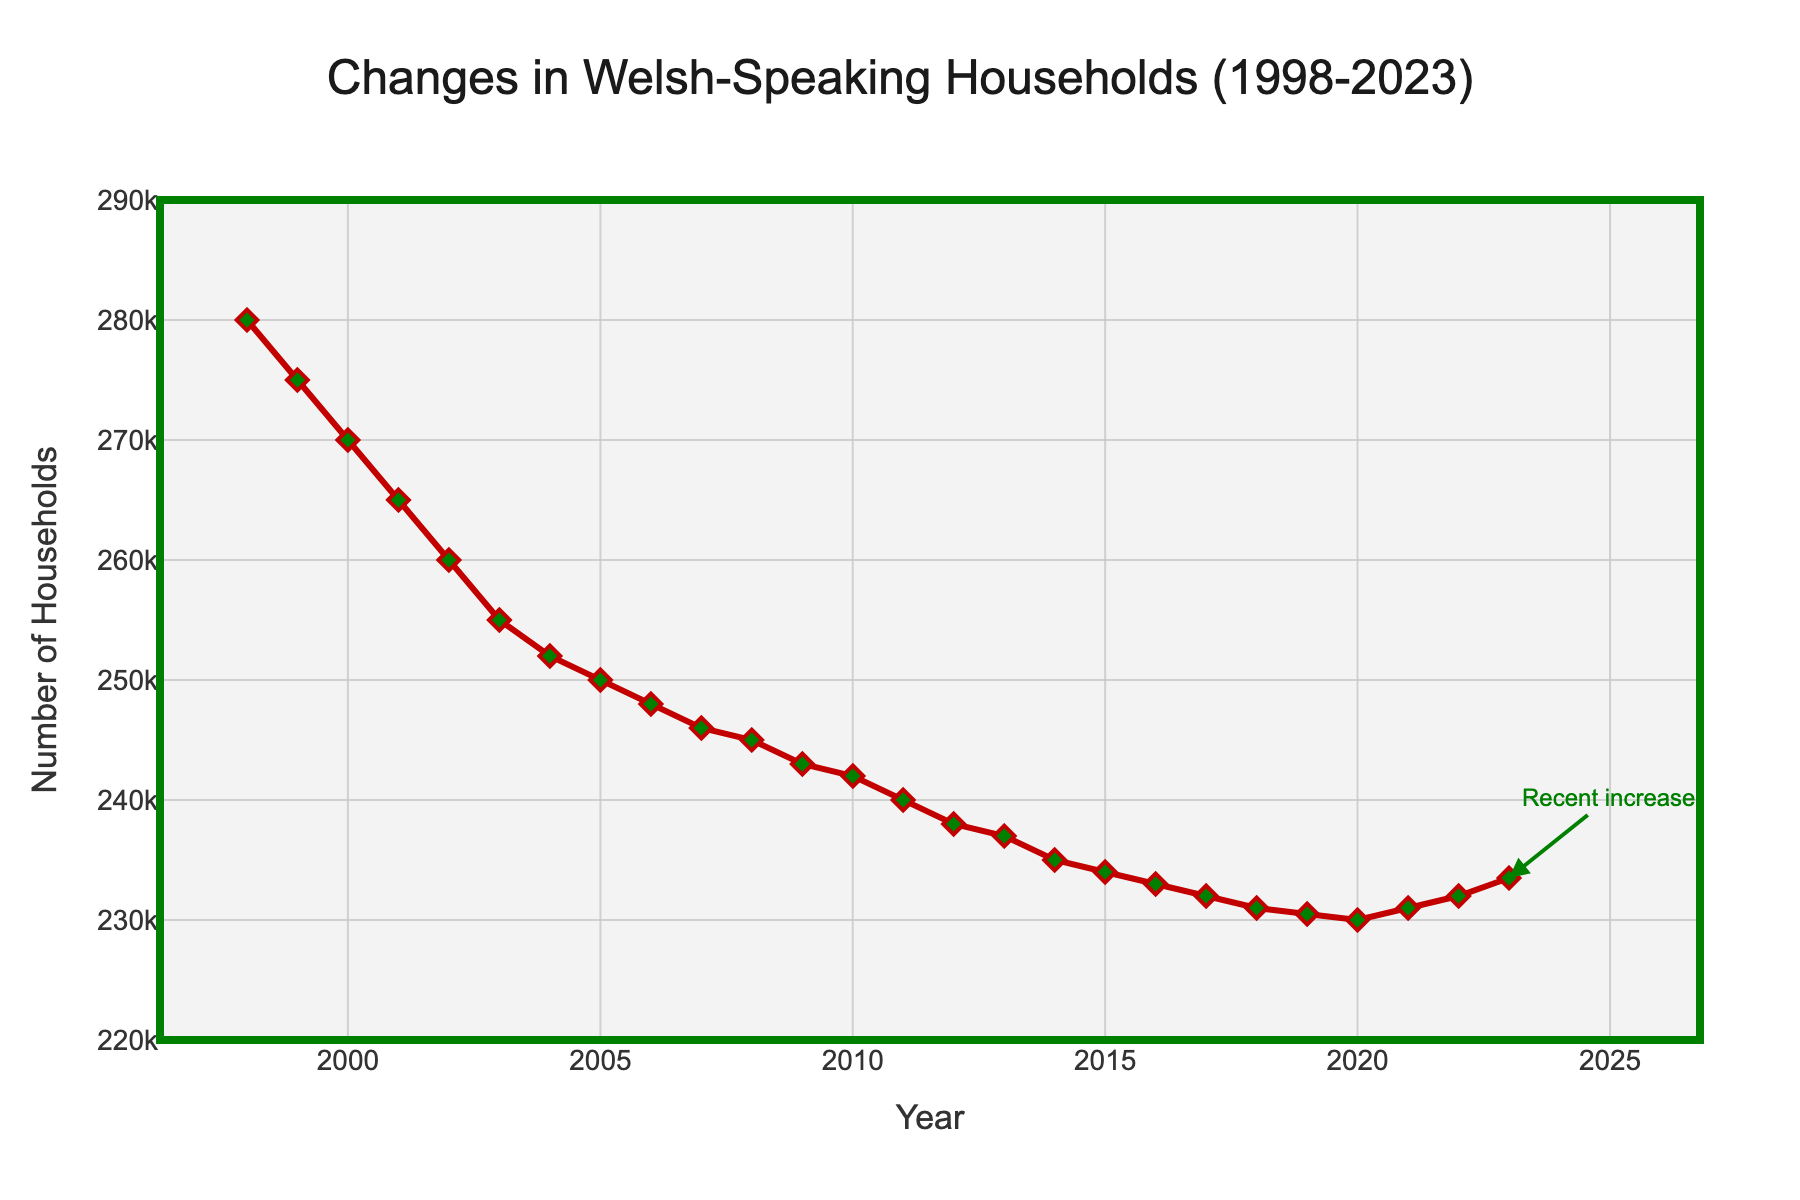What is the title of the plot? The title is found at the top of the plot.
Answer: Changes in Welsh-Speaking Households (1998-2023) How many data points are in the plot? The x-axis spans from 1998 to 2023, inclusive. Counting each year, there are 26 points.
Answer: 26 What is the range of the y-axis? The y-axis begins at 220,000 and ends at 290,000.
Answer: 220,000 to 290,000 In which year did the number of Welsh-speaking households reach its lowest point? Identify the lowest point on the plot, which occurs around 2020.
Answer: 2020 What significant trend occurred after the year 2020? The plot shows an upward trend in the number of Welsh-speaking households from 2020 onwards.
Answer: Increase How many households spoke Welsh in 1998 compared to 2021? Look at the y-values for the years 1998 and 2021. 1998 shows 280,000 and 2021 shows 231,000.
Answer: 280,000 in 1998 and 231,000 in 2021 What is the average number of Welsh-speaking households from 1998 to 2023? Sum the values and divide by the number of data points (26). The sum is 6,020,500, so the average is 6,020,500 / 26.
Answer: ~231,558 Compare the values in 2000 and 2023. Which year had more Welsh-speaking households and by how much? 2000 had 270,000 households, while 2023 had 233,500. Calculate the difference: 270,000 - 233,500.
Answer: 2000 by 36,500 What pattern can be observed in the trend from 1998 through 2016? The number of Welsh-speaking households consistently decreases from 1998 until 2016.
Answer: A consistent decrease How did the number of Welsh-speaking households change between 2018 and 2019? 2018 shows 231,000 and 2019 shows 230,500. Subtract to find the difference: 231,000 - 230,500.
Answer: Decreased by 500 